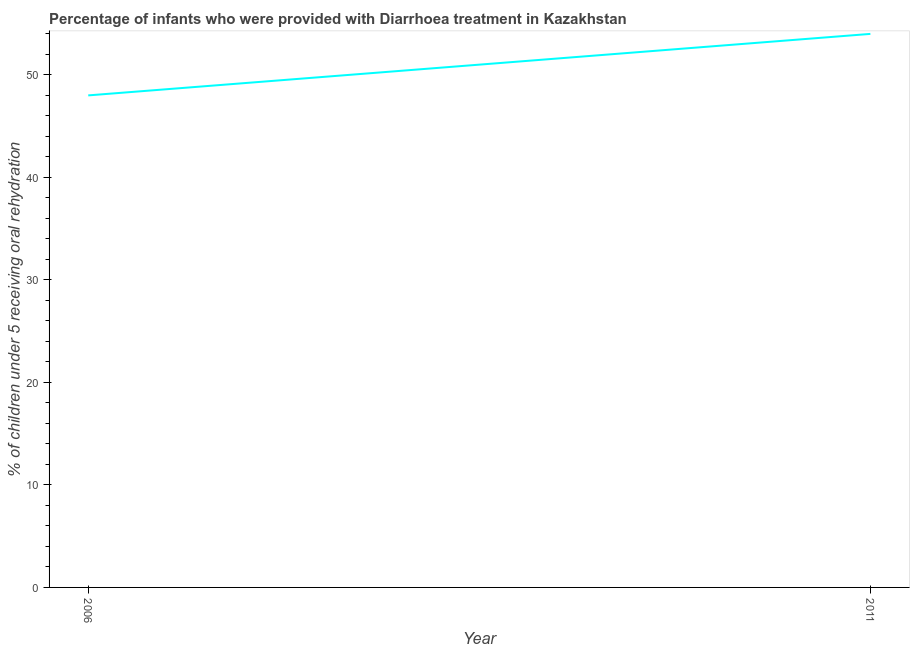What is the percentage of children who were provided with treatment diarrhoea in 2011?
Your answer should be very brief. 54. Across all years, what is the maximum percentage of children who were provided with treatment diarrhoea?
Offer a terse response. 54. Across all years, what is the minimum percentage of children who were provided with treatment diarrhoea?
Your response must be concise. 48. In which year was the percentage of children who were provided with treatment diarrhoea maximum?
Your answer should be compact. 2011. What is the sum of the percentage of children who were provided with treatment diarrhoea?
Offer a terse response. 102. What is the difference between the percentage of children who were provided with treatment diarrhoea in 2006 and 2011?
Your answer should be very brief. -6. In how many years, is the percentage of children who were provided with treatment diarrhoea greater than 18 %?
Offer a very short reply. 2. Do a majority of the years between 2006 and 2011 (inclusive) have percentage of children who were provided with treatment diarrhoea greater than 52 %?
Make the answer very short. No. What is the ratio of the percentage of children who were provided with treatment diarrhoea in 2006 to that in 2011?
Keep it short and to the point. 0.89. Is the percentage of children who were provided with treatment diarrhoea in 2006 less than that in 2011?
Provide a succinct answer. Yes. Does the percentage of children who were provided with treatment diarrhoea monotonically increase over the years?
Your answer should be very brief. Yes. How many lines are there?
Your response must be concise. 1. What is the difference between two consecutive major ticks on the Y-axis?
Make the answer very short. 10. Are the values on the major ticks of Y-axis written in scientific E-notation?
Your answer should be very brief. No. Does the graph contain grids?
Your answer should be very brief. No. What is the title of the graph?
Your response must be concise. Percentage of infants who were provided with Diarrhoea treatment in Kazakhstan. What is the label or title of the Y-axis?
Your answer should be compact. % of children under 5 receiving oral rehydration. What is the % of children under 5 receiving oral rehydration of 2006?
Provide a short and direct response. 48. What is the ratio of the % of children under 5 receiving oral rehydration in 2006 to that in 2011?
Give a very brief answer. 0.89. 